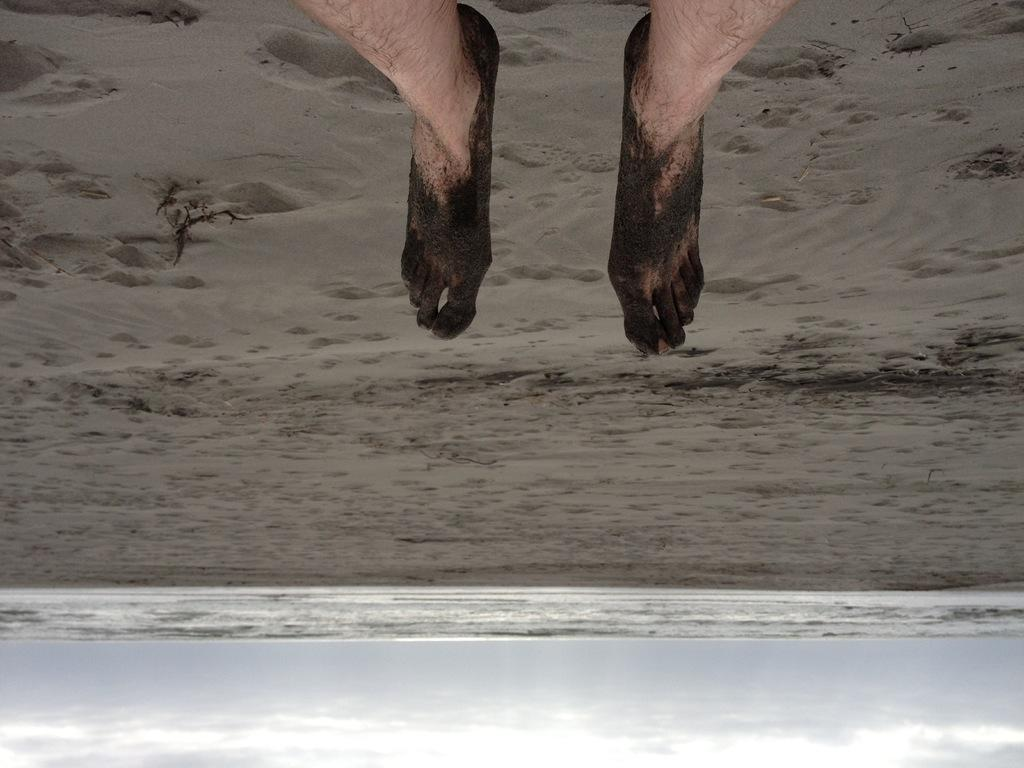What is: What part of a person's body is visible in the image? There are person's legs visible in the image. What type of surface are the legs on? The legs are on the sand. What natural body of water can be seen in the image? The sea is visible in the image. What else is visible in the sky besides the clouds? The sky is visible in the image, but there is no mention of anything else besides the clouds. What type of legal advice can be sought from the lawyer in the image? There is no lawyer present in the image; it only features a person's legs on the sand. How many ladybugs can be seen crawling on the root in the image? There is no root or ladybugs present in the image. 